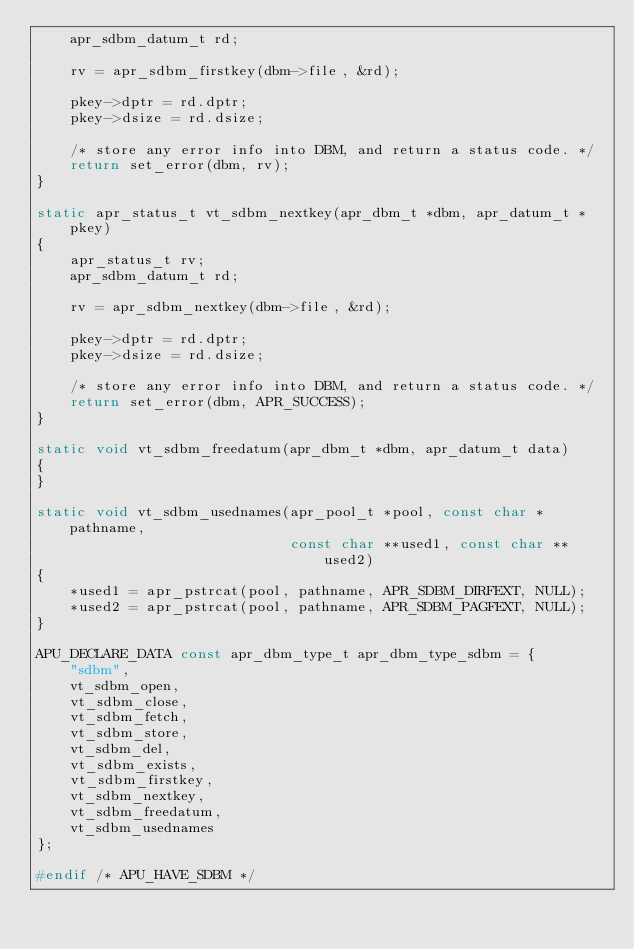Convert code to text. <code><loc_0><loc_0><loc_500><loc_500><_C_>    apr_sdbm_datum_t rd;

    rv = apr_sdbm_firstkey(dbm->file, &rd);

    pkey->dptr = rd.dptr;
    pkey->dsize = rd.dsize;

    /* store any error info into DBM, and return a status code. */
    return set_error(dbm, rv);
}

static apr_status_t vt_sdbm_nextkey(apr_dbm_t *dbm, apr_datum_t *pkey)
{
    apr_status_t rv;
    apr_sdbm_datum_t rd;

    rv = apr_sdbm_nextkey(dbm->file, &rd);

    pkey->dptr = rd.dptr;
    pkey->dsize = rd.dsize;

    /* store any error info into DBM, and return a status code. */
    return set_error(dbm, APR_SUCCESS);
}

static void vt_sdbm_freedatum(apr_dbm_t *dbm, apr_datum_t data)
{
}

static void vt_sdbm_usednames(apr_pool_t *pool, const char *pathname,
                              const char **used1, const char **used2)
{
    *used1 = apr_pstrcat(pool, pathname, APR_SDBM_DIRFEXT, NULL);
    *used2 = apr_pstrcat(pool, pathname, APR_SDBM_PAGFEXT, NULL);
}

APU_DECLARE_DATA const apr_dbm_type_t apr_dbm_type_sdbm = {
    "sdbm",
    vt_sdbm_open,
    vt_sdbm_close,
    vt_sdbm_fetch,
    vt_sdbm_store,
    vt_sdbm_del,
    vt_sdbm_exists,
    vt_sdbm_firstkey,
    vt_sdbm_nextkey,
    vt_sdbm_freedatum,
    vt_sdbm_usednames
};

#endif /* APU_HAVE_SDBM */
</code> 